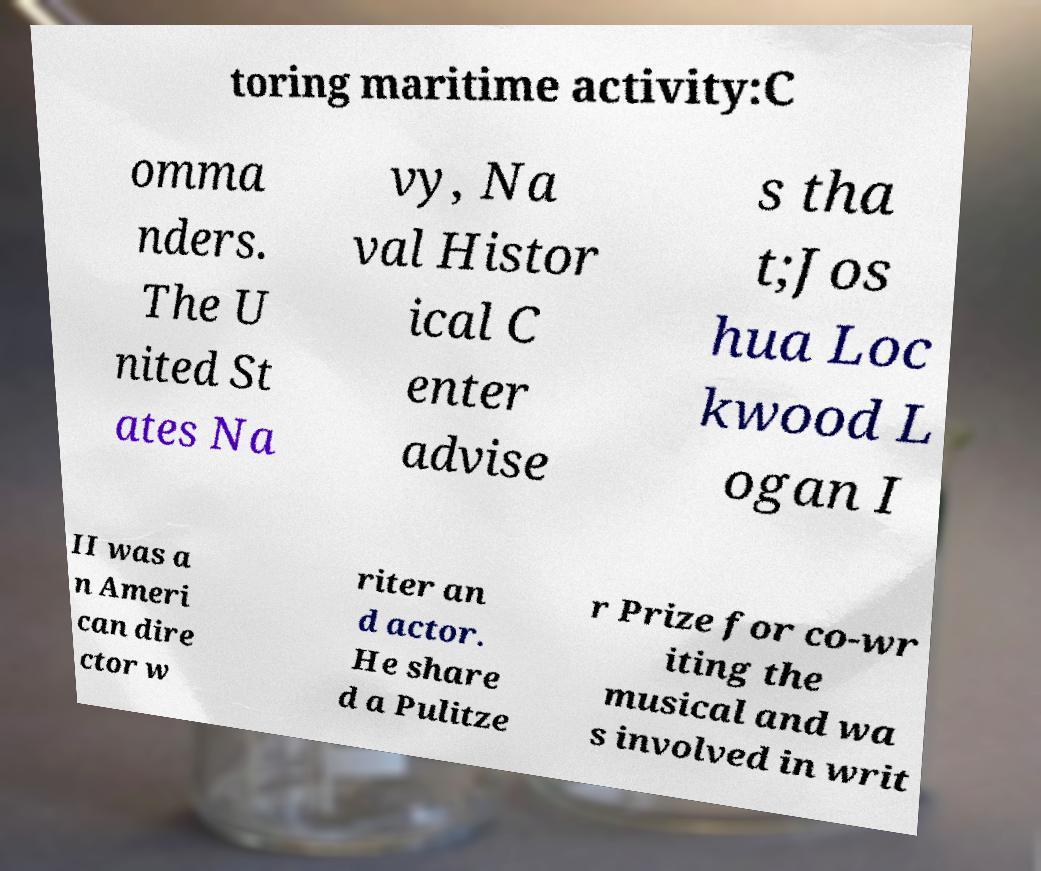Can you read and provide the text displayed in the image?This photo seems to have some interesting text. Can you extract and type it out for me? toring maritime activity:C omma nders. The U nited St ates Na vy, Na val Histor ical C enter advise s tha t;Jos hua Loc kwood L ogan I II was a n Ameri can dire ctor w riter an d actor. He share d a Pulitze r Prize for co-wr iting the musical and wa s involved in writ 